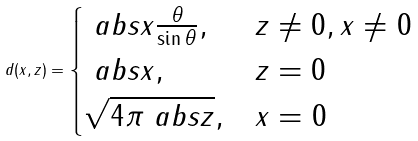Convert formula to latex. <formula><loc_0><loc_0><loc_500><loc_500>d ( x , z ) = \begin{cases} \ a b s { x } \frac { \theta } { \sin \theta } , & z \ne 0 , x \ne 0 \\ \ a b s { x } , & z = 0 \\ \sqrt { 4 \pi \ a b s { z } } , & x = 0 \end{cases}</formula> 